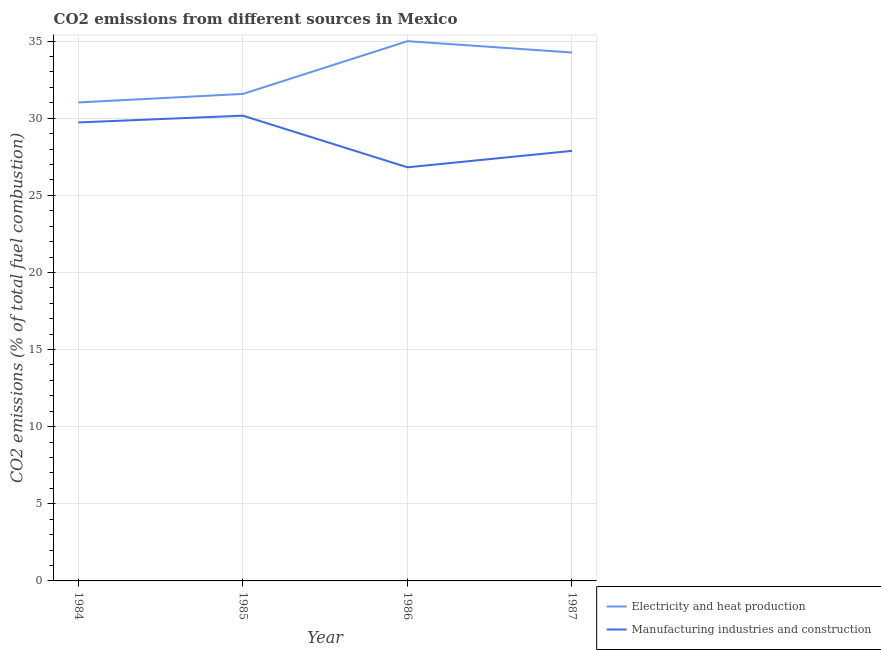How many different coloured lines are there?
Provide a short and direct response. 2. Does the line corresponding to co2 emissions due to electricity and heat production intersect with the line corresponding to co2 emissions due to manufacturing industries?
Ensure brevity in your answer.  No. What is the co2 emissions due to electricity and heat production in 1985?
Provide a succinct answer. 31.58. Across all years, what is the maximum co2 emissions due to manufacturing industries?
Provide a short and direct response. 30.17. Across all years, what is the minimum co2 emissions due to manufacturing industries?
Your answer should be compact. 26.82. In which year was the co2 emissions due to electricity and heat production maximum?
Give a very brief answer. 1986. In which year was the co2 emissions due to electricity and heat production minimum?
Give a very brief answer. 1984. What is the total co2 emissions due to electricity and heat production in the graph?
Give a very brief answer. 131.86. What is the difference between the co2 emissions due to electricity and heat production in 1985 and that in 1987?
Provide a succinct answer. -2.69. What is the difference between the co2 emissions due to electricity and heat production in 1985 and the co2 emissions due to manufacturing industries in 1984?
Provide a succinct answer. 1.85. What is the average co2 emissions due to manufacturing industries per year?
Your response must be concise. 28.65. In the year 1984, what is the difference between the co2 emissions due to electricity and heat production and co2 emissions due to manufacturing industries?
Keep it short and to the point. 1.3. What is the ratio of the co2 emissions due to electricity and heat production in 1984 to that in 1987?
Provide a short and direct response. 0.91. Is the co2 emissions due to manufacturing industries in 1985 less than that in 1987?
Make the answer very short. No. Is the difference between the co2 emissions due to manufacturing industries in 1984 and 1986 greater than the difference between the co2 emissions due to electricity and heat production in 1984 and 1986?
Provide a short and direct response. Yes. What is the difference between the highest and the second highest co2 emissions due to electricity and heat production?
Offer a terse response. 0.73. What is the difference between the highest and the lowest co2 emissions due to electricity and heat production?
Your answer should be compact. 3.97. Does the co2 emissions due to electricity and heat production monotonically increase over the years?
Provide a succinct answer. No. Is the co2 emissions due to manufacturing industries strictly less than the co2 emissions due to electricity and heat production over the years?
Offer a very short reply. Yes. How many lines are there?
Give a very brief answer. 2. How many years are there in the graph?
Your response must be concise. 4. What is the difference between two consecutive major ticks on the Y-axis?
Your answer should be compact. 5. Does the graph contain any zero values?
Your answer should be compact. No. Where does the legend appear in the graph?
Your answer should be compact. Bottom right. How many legend labels are there?
Ensure brevity in your answer.  2. How are the legend labels stacked?
Offer a terse response. Vertical. What is the title of the graph?
Provide a succinct answer. CO2 emissions from different sources in Mexico. Does "Register a property" appear as one of the legend labels in the graph?
Your answer should be very brief. No. What is the label or title of the Y-axis?
Your answer should be very brief. CO2 emissions (% of total fuel combustion). What is the CO2 emissions (% of total fuel combustion) in Electricity and heat production in 1984?
Your response must be concise. 31.02. What is the CO2 emissions (% of total fuel combustion) of Manufacturing industries and construction in 1984?
Your answer should be very brief. 29.73. What is the CO2 emissions (% of total fuel combustion) in Electricity and heat production in 1985?
Provide a succinct answer. 31.58. What is the CO2 emissions (% of total fuel combustion) in Manufacturing industries and construction in 1985?
Give a very brief answer. 30.17. What is the CO2 emissions (% of total fuel combustion) of Electricity and heat production in 1986?
Offer a terse response. 35. What is the CO2 emissions (% of total fuel combustion) of Manufacturing industries and construction in 1986?
Offer a very short reply. 26.82. What is the CO2 emissions (% of total fuel combustion) in Electricity and heat production in 1987?
Provide a succinct answer. 34.26. What is the CO2 emissions (% of total fuel combustion) in Manufacturing industries and construction in 1987?
Your response must be concise. 27.88. Across all years, what is the maximum CO2 emissions (% of total fuel combustion) of Electricity and heat production?
Your answer should be very brief. 35. Across all years, what is the maximum CO2 emissions (% of total fuel combustion) of Manufacturing industries and construction?
Provide a short and direct response. 30.17. Across all years, what is the minimum CO2 emissions (% of total fuel combustion) of Electricity and heat production?
Provide a short and direct response. 31.02. Across all years, what is the minimum CO2 emissions (% of total fuel combustion) in Manufacturing industries and construction?
Provide a succinct answer. 26.82. What is the total CO2 emissions (% of total fuel combustion) in Electricity and heat production in the graph?
Your answer should be compact. 131.86. What is the total CO2 emissions (% of total fuel combustion) in Manufacturing industries and construction in the graph?
Offer a very short reply. 114.59. What is the difference between the CO2 emissions (% of total fuel combustion) in Electricity and heat production in 1984 and that in 1985?
Keep it short and to the point. -0.55. What is the difference between the CO2 emissions (% of total fuel combustion) in Manufacturing industries and construction in 1984 and that in 1985?
Offer a terse response. -0.44. What is the difference between the CO2 emissions (% of total fuel combustion) of Electricity and heat production in 1984 and that in 1986?
Make the answer very short. -3.97. What is the difference between the CO2 emissions (% of total fuel combustion) in Manufacturing industries and construction in 1984 and that in 1986?
Your answer should be compact. 2.91. What is the difference between the CO2 emissions (% of total fuel combustion) in Electricity and heat production in 1984 and that in 1987?
Your answer should be compact. -3.24. What is the difference between the CO2 emissions (% of total fuel combustion) of Manufacturing industries and construction in 1984 and that in 1987?
Your answer should be very brief. 1.84. What is the difference between the CO2 emissions (% of total fuel combustion) in Electricity and heat production in 1985 and that in 1986?
Offer a very short reply. -3.42. What is the difference between the CO2 emissions (% of total fuel combustion) in Manufacturing industries and construction in 1985 and that in 1986?
Your answer should be very brief. 3.35. What is the difference between the CO2 emissions (% of total fuel combustion) of Electricity and heat production in 1985 and that in 1987?
Your answer should be compact. -2.69. What is the difference between the CO2 emissions (% of total fuel combustion) of Manufacturing industries and construction in 1985 and that in 1987?
Your response must be concise. 2.28. What is the difference between the CO2 emissions (% of total fuel combustion) in Electricity and heat production in 1986 and that in 1987?
Ensure brevity in your answer.  0.73. What is the difference between the CO2 emissions (% of total fuel combustion) in Manufacturing industries and construction in 1986 and that in 1987?
Offer a terse response. -1.07. What is the difference between the CO2 emissions (% of total fuel combustion) in Electricity and heat production in 1984 and the CO2 emissions (% of total fuel combustion) in Manufacturing industries and construction in 1985?
Your answer should be very brief. 0.86. What is the difference between the CO2 emissions (% of total fuel combustion) in Electricity and heat production in 1984 and the CO2 emissions (% of total fuel combustion) in Manufacturing industries and construction in 1986?
Give a very brief answer. 4.21. What is the difference between the CO2 emissions (% of total fuel combustion) of Electricity and heat production in 1984 and the CO2 emissions (% of total fuel combustion) of Manufacturing industries and construction in 1987?
Keep it short and to the point. 3.14. What is the difference between the CO2 emissions (% of total fuel combustion) of Electricity and heat production in 1985 and the CO2 emissions (% of total fuel combustion) of Manufacturing industries and construction in 1986?
Make the answer very short. 4.76. What is the difference between the CO2 emissions (% of total fuel combustion) in Electricity and heat production in 1985 and the CO2 emissions (% of total fuel combustion) in Manufacturing industries and construction in 1987?
Your response must be concise. 3.69. What is the difference between the CO2 emissions (% of total fuel combustion) in Electricity and heat production in 1986 and the CO2 emissions (% of total fuel combustion) in Manufacturing industries and construction in 1987?
Offer a terse response. 7.11. What is the average CO2 emissions (% of total fuel combustion) of Electricity and heat production per year?
Keep it short and to the point. 32.96. What is the average CO2 emissions (% of total fuel combustion) in Manufacturing industries and construction per year?
Make the answer very short. 28.65. In the year 1984, what is the difference between the CO2 emissions (% of total fuel combustion) in Electricity and heat production and CO2 emissions (% of total fuel combustion) in Manufacturing industries and construction?
Ensure brevity in your answer.  1.3. In the year 1985, what is the difference between the CO2 emissions (% of total fuel combustion) in Electricity and heat production and CO2 emissions (% of total fuel combustion) in Manufacturing industries and construction?
Offer a terse response. 1.41. In the year 1986, what is the difference between the CO2 emissions (% of total fuel combustion) of Electricity and heat production and CO2 emissions (% of total fuel combustion) of Manufacturing industries and construction?
Your answer should be compact. 8.18. In the year 1987, what is the difference between the CO2 emissions (% of total fuel combustion) in Electricity and heat production and CO2 emissions (% of total fuel combustion) in Manufacturing industries and construction?
Offer a very short reply. 6.38. What is the ratio of the CO2 emissions (% of total fuel combustion) in Electricity and heat production in 1984 to that in 1985?
Offer a terse response. 0.98. What is the ratio of the CO2 emissions (% of total fuel combustion) in Manufacturing industries and construction in 1984 to that in 1985?
Offer a very short reply. 0.99. What is the ratio of the CO2 emissions (% of total fuel combustion) in Electricity and heat production in 1984 to that in 1986?
Provide a short and direct response. 0.89. What is the ratio of the CO2 emissions (% of total fuel combustion) of Manufacturing industries and construction in 1984 to that in 1986?
Your answer should be very brief. 1.11. What is the ratio of the CO2 emissions (% of total fuel combustion) of Electricity and heat production in 1984 to that in 1987?
Provide a short and direct response. 0.91. What is the ratio of the CO2 emissions (% of total fuel combustion) in Manufacturing industries and construction in 1984 to that in 1987?
Provide a succinct answer. 1.07. What is the ratio of the CO2 emissions (% of total fuel combustion) in Electricity and heat production in 1985 to that in 1986?
Give a very brief answer. 0.9. What is the ratio of the CO2 emissions (% of total fuel combustion) in Manufacturing industries and construction in 1985 to that in 1986?
Ensure brevity in your answer.  1.12. What is the ratio of the CO2 emissions (% of total fuel combustion) in Electricity and heat production in 1985 to that in 1987?
Give a very brief answer. 0.92. What is the ratio of the CO2 emissions (% of total fuel combustion) of Manufacturing industries and construction in 1985 to that in 1987?
Provide a short and direct response. 1.08. What is the ratio of the CO2 emissions (% of total fuel combustion) in Electricity and heat production in 1986 to that in 1987?
Your answer should be very brief. 1.02. What is the ratio of the CO2 emissions (% of total fuel combustion) in Manufacturing industries and construction in 1986 to that in 1987?
Give a very brief answer. 0.96. What is the difference between the highest and the second highest CO2 emissions (% of total fuel combustion) of Electricity and heat production?
Keep it short and to the point. 0.73. What is the difference between the highest and the second highest CO2 emissions (% of total fuel combustion) in Manufacturing industries and construction?
Provide a succinct answer. 0.44. What is the difference between the highest and the lowest CO2 emissions (% of total fuel combustion) in Electricity and heat production?
Provide a succinct answer. 3.97. What is the difference between the highest and the lowest CO2 emissions (% of total fuel combustion) of Manufacturing industries and construction?
Your answer should be compact. 3.35. 